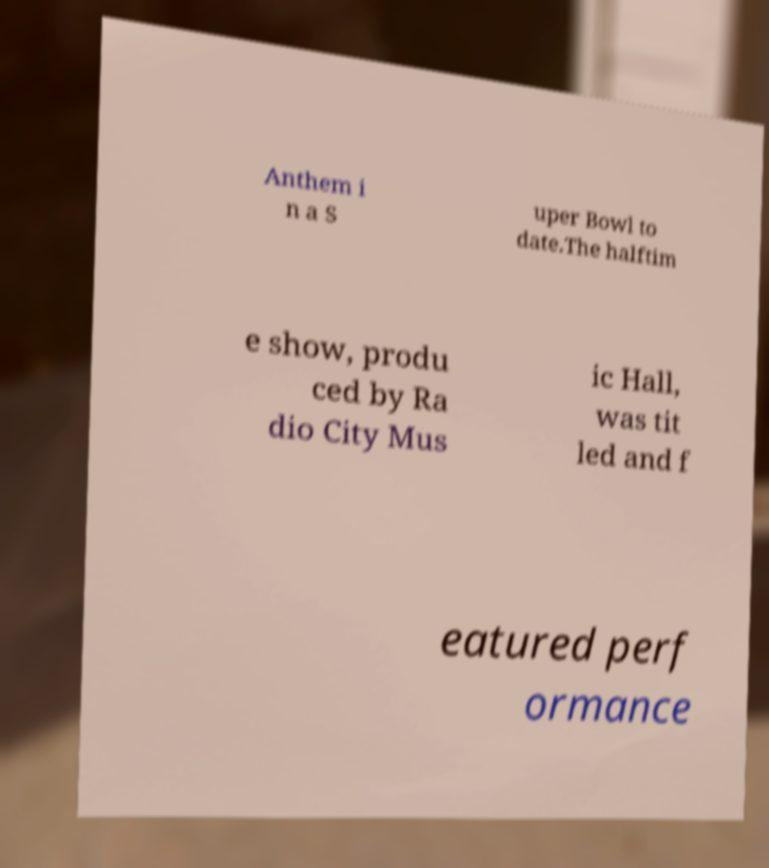Please identify and transcribe the text found in this image. Anthem i n a S uper Bowl to date.The halftim e show, produ ced by Ra dio City Mus ic Hall, was tit led and f eatured perf ormance 